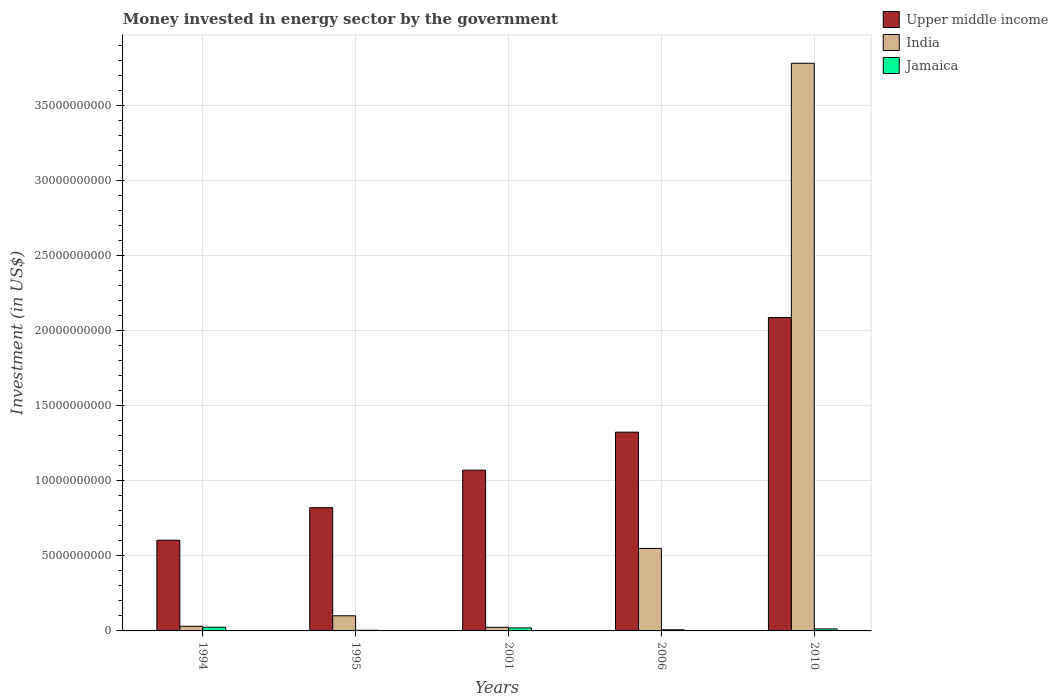How many different coloured bars are there?
Your response must be concise. 3. How many groups of bars are there?
Provide a short and direct response. 5. Are the number of bars per tick equal to the number of legend labels?
Make the answer very short. Yes. Are the number of bars on each tick of the X-axis equal?
Provide a succinct answer. Yes. How many bars are there on the 3rd tick from the right?
Offer a very short reply. 3. What is the label of the 4th group of bars from the left?
Your answer should be compact. 2006. In how many cases, is the number of bars for a given year not equal to the number of legend labels?
Provide a succinct answer. 0. What is the money spent in energy sector in Upper middle income in 1995?
Give a very brief answer. 8.21e+09. Across all years, what is the maximum money spent in energy sector in Jamaica?
Ensure brevity in your answer.  2.46e+08. Across all years, what is the minimum money spent in energy sector in India?
Your answer should be very brief. 2.40e+08. In which year was the money spent in energy sector in India minimum?
Offer a very short reply. 2001. What is the total money spent in energy sector in Jamaica in the graph?
Your answer should be compact. 7.00e+08. What is the difference between the money spent in energy sector in Jamaica in 2001 and that in 2006?
Offer a terse response. 1.23e+08. What is the difference between the money spent in energy sector in India in 2001 and the money spent in energy sector in Upper middle income in 1995?
Offer a terse response. -7.97e+09. What is the average money spent in energy sector in India per year?
Provide a short and direct response. 8.98e+09. In the year 2010, what is the difference between the money spent in energy sector in Jamaica and money spent in energy sector in Upper middle income?
Ensure brevity in your answer.  -2.08e+1. In how many years, is the money spent in energy sector in Jamaica greater than 34000000000 US$?
Your response must be concise. 0. What is the ratio of the money spent in energy sector in India in 2006 to that in 2010?
Offer a terse response. 0.15. Is the money spent in energy sector in Jamaica in 2006 less than that in 2010?
Provide a short and direct response. Yes. What is the difference between the highest and the second highest money spent in energy sector in Jamaica?
Give a very brief answer. 4.50e+07. What is the difference between the highest and the lowest money spent in energy sector in Upper middle income?
Your answer should be compact. 1.48e+1. In how many years, is the money spent in energy sector in India greater than the average money spent in energy sector in India taken over all years?
Provide a succinct answer. 1. What does the 1st bar from the left in 1994 represents?
Make the answer very short. Upper middle income. What does the 1st bar from the right in 2010 represents?
Offer a very short reply. Jamaica. How many years are there in the graph?
Offer a terse response. 5. What is the difference between two consecutive major ticks on the Y-axis?
Keep it short and to the point. 5.00e+09. Are the values on the major ticks of Y-axis written in scientific E-notation?
Give a very brief answer. No. How many legend labels are there?
Keep it short and to the point. 3. What is the title of the graph?
Provide a succinct answer. Money invested in energy sector by the government. Does "Isle of Man" appear as one of the legend labels in the graph?
Give a very brief answer. No. What is the label or title of the Y-axis?
Your response must be concise. Investment (in US$). What is the Investment (in US$) in Upper middle income in 1994?
Provide a succinct answer. 6.05e+09. What is the Investment (in US$) in India in 1994?
Keep it short and to the point. 3.11e+08. What is the Investment (in US$) in Jamaica in 1994?
Provide a short and direct response. 2.46e+08. What is the Investment (in US$) in Upper middle income in 1995?
Provide a succinct answer. 8.21e+09. What is the Investment (in US$) of India in 1995?
Provide a succinct answer. 1.01e+09. What is the Investment (in US$) in Jamaica in 1995?
Give a very brief answer. 4.30e+07. What is the Investment (in US$) of Upper middle income in 2001?
Provide a succinct answer. 1.07e+1. What is the Investment (in US$) of India in 2001?
Provide a succinct answer. 2.40e+08. What is the Investment (in US$) in Jamaica in 2001?
Your answer should be very brief. 2.01e+08. What is the Investment (in US$) in Upper middle income in 2006?
Your answer should be very brief. 1.32e+1. What is the Investment (in US$) in India in 2006?
Offer a very short reply. 5.50e+09. What is the Investment (in US$) of Jamaica in 2006?
Provide a short and direct response. 7.80e+07. What is the Investment (in US$) of Upper middle income in 2010?
Provide a short and direct response. 2.09e+1. What is the Investment (in US$) of India in 2010?
Offer a terse response. 3.78e+1. What is the Investment (in US$) in Jamaica in 2010?
Your response must be concise. 1.32e+08. Across all years, what is the maximum Investment (in US$) of Upper middle income?
Your response must be concise. 2.09e+1. Across all years, what is the maximum Investment (in US$) in India?
Ensure brevity in your answer.  3.78e+1. Across all years, what is the maximum Investment (in US$) of Jamaica?
Provide a short and direct response. 2.46e+08. Across all years, what is the minimum Investment (in US$) in Upper middle income?
Keep it short and to the point. 6.05e+09. Across all years, what is the minimum Investment (in US$) in India?
Make the answer very short. 2.40e+08. Across all years, what is the minimum Investment (in US$) in Jamaica?
Ensure brevity in your answer.  4.30e+07. What is the total Investment (in US$) of Upper middle income in the graph?
Provide a short and direct response. 5.91e+1. What is the total Investment (in US$) of India in the graph?
Keep it short and to the point. 4.49e+1. What is the total Investment (in US$) in Jamaica in the graph?
Give a very brief answer. 7.00e+08. What is the difference between the Investment (in US$) in Upper middle income in 1994 and that in 1995?
Make the answer very short. -2.17e+09. What is the difference between the Investment (in US$) of India in 1994 and that in 1995?
Keep it short and to the point. -6.97e+08. What is the difference between the Investment (in US$) in Jamaica in 1994 and that in 1995?
Give a very brief answer. 2.03e+08. What is the difference between the Investment (in US$) of Upper middle income in 1994 and that in 2001?
Your answer should be very brief. -4.67e+09. What is the difference between the Investment (in US$) of India in 1994 and that in 2001?
Offer a very short reply. 7.13e+07. What is the difference between the Investment (in US$) of Jamaica in 1994 and that in 2001?
Offer a very short reply. 4.50e+07. What is the difference between the Investment (in US$) in Upper middle income in 1994 and that in 2006?
Your answer should be very brief. -7.20e+09. What is the difference between the Investment (in US$) of India in 1994 and that in 2006?
Provide a succinct answer. -5.19e+09. What is the difference between the Investment (in US$) in Jamaica in 1994 and that in 2006?
Offer a very short reply. 1.68e+08. What is the difference between the Investment (in US$) of Upper middle income in 1994 and that in 2010?
Keep it short and to the point. -1.48e+1. What is the difference between the Investment (in US$) in India in 1994 and that in 2010?
Offer a terse response. -3.75e+1. What is the difference between the Investment (in US$) of Jamaica in 1994 and that in 2010?
Ensure brevity in your answer.  1.14e+08. What is the difference between the Investment (in US$) in Upper middle income in 1995 and that in 2001?
Provide a short and direct response. -2.50e+09. What is the difference between the Investment (in US$) in India in 1995 and that in 2001?
Offer a very short reply. 7.68e+08. What is the difference between the Investment (in US$) of Jamaica in 1995 and that in 2001?
Provide a succinct answer. -1.58e+08. What is the difference between the Investment (in US$) of Upper middle income in 1995 and that in 2006?
Offer a very short reply. -5.04e+09. What is the difference between the Investment (in US$) of India in 1995 and that in 2006?
Your answer should be very brief. -4.49e+09. What is the difference between the Investment (in US$) of Jamaica in 1995 and that in 2006?
Make the answer very short. -3.50e+07. What is the difference between the Investment (in US$) of Upper middle income in 1995 and that in 2010?
Ensure brevity in your answer.  -1.27e+1. What is the difference between the Investment (in US$) of India in 1995 and that in 2010?
Provide a short and direct response. -3.68e+1. What is the difference between the Investment (in US$) in Jamaica in 1995 and that in 2010?
Your answer should be compact. -8.90e+07. What is the difference between the Investment (in US$) in Upper middle income in 2001 and that in 2006?
Give a very brief answer. -2.54e+09. What is the difference between the Investment (in US$) of India in 2001 and that in 2006?
Your answer should be compact. -5.26e+09. What is the difference between the Investment (in US$) in Jamaica in 2001 and that in 2006?
Your answer should be compact. 1.23e+08. What is the difference between the Investment (in US$) of Upper middle income in 2001 and that in 2010?
Your answer should be very brief. -1.02e+1. What is the difference between the Investment (in US$) of India in 2001 and that in 2010?
Offer a very short reply. -3.76e+1. What is the difference between the Investment (in US$) of Jamaica in 2001 and that in 2010?
Provide a succinct answer. 6.90e+07. What is the difference between the Investment (in US$) of Upper middle income in 2006 and that in 2010?
Make the answer very short. -7.64e+09. What is the difference between the Investment (in US$) in India in 2006 and that in 2010?
Ensure brevity in your answer.  -3.23e+1. What is the difference between the Investment (in US$) in Jamaica in 2006 and that in 2010?
Offer a terse response. -5.40e+07. What is the difference between the Investment (in US$) of Upper middle income in 1994 and the Investment (in US$) of India in 1995?
Ensure brevity in your answer.  5.04e+09. What is the difference between the Investment (in US$) of Upper middle income in 1994 and the Investment (in US$) of Jamaica in 1995?
Give a very brief answer. 6.00e+09. What is the difference between the Investment (in US$) in India in 1994 and the Investment (in US$) in Jamaica in 1995?
Make the answer very short. 2.68e+08. What is the difference between the Investment (in US$) in Upper middle income in 1994 and the Investment (in US$) in India in 2001?
Offer a terse response. 5.81e+09. What is the difference between the Investment (in US$) of Upper middle income in 1994 and the Investment (in US$) of Jamaica in 2001?
Your answer should be very brief. 5.84e+09. What is the difference between the Investment (in US$) in India in 1994 and the Investment (in US$) in Jamaica in 2001?
Give a very brief answer. 1.10e+08. What is the difference between the Investment (in US$) of Upper middle income in 1994 and the Investment (in US$) of India in 2006?
Ensure brevity in your answer.  5.45e+08. What is the difference between the Investment (in US$) of Upper middle income in 1994 and the Investment (in US$) of Jamaica in 2006?
Ensure brevity in your answer.  5.97e+09. What is the difference between the Investment (in US$) of India in 1994 and the Investment (in US$) of Jamaica in 2006?
Keep it short and to the point. 2.33e+08. What is the difference between the Investment (in US$) in Upper middle income in 1994 and the Investment (in US$) in India in 2010?
Make the answer very short. -3.18e+1. What is the difference between the Investment (in US$) in Upper middle income in 1994 and the Investment (in US$) in Jamaica in 2010?
Provide a succinct answer. 5.91e+09. What is the difference between the Investment (in US$) of India in 1994 and the Investment (in US$) of Jamaica in 2010?
Your answer should be compact. 1.79e+08. What is the difference between the Investment (in US$) of Upper middle income in 1995 and the Investment (in US$) of India in 2001?
Your response must be concise. 7.97e+09. What is the difference between the Investment (in US$) in Upper middle income in 1995 and the Investment (in US$) in Jamaica in 2001?
Offer a terse response. 8.01e+09. What is the difference between the Investment (in US$) of India in 1995 and the Investment (in US$) of Jamaica in 2001?
Provide a short and direct response. 8.07e+08. What is the difference between the Investment (in US$) in Upper middle income in 1995 and the Investment (in US$) in India in 2006?
Provide a short and direct response. 2.71e+09. What is the difference between the Investment (in US$) in Upper middle income in 1995 and the Investment (in US$) in Jamaica in 2006?
Provide a short and direct response. 8.14e+09. What is the difference between the Investment (in US$) in India in 1995 and the Investment (in US$) in Jamaica in 2006?
Your answer should be compact. 9.30e+08. What is the difference between the Investment (in US$) of Upper middle income in 1995 and the Investment (in US$) of India in 2010?
Provide a short and direct response. -2.96e+1. What is the difference between the Investment (in US$) of Upper middle income in 1995 and the Investment (in US$) of Jamaica in 2010?
Your response must be concise. 8.08e+09. What is the difference between the Investment (in US$) in India in 1995 and the Investment (in US$) in Jamaica in 2010?
Provide a short and direct response. 8.76e+08. What is the difference between the Investment (in US$) of Upper middle income in 2001 and the Investment (in US$) of India in 2006?
Make the answer very short. 5.21e+09. What is the difference between the Investment (in US$) of Upper middle income in 2001 and the Investment (in US$) of Jamaica in 2006?
Offer a very short reply. 1.06e+1. What is the difference between the Investment (in US$) of India in 2001 and the Investment (in US$) of Jamaica in 2006?
Ensure brevity in your answer.  1.62e+08. What is the difference between the Investment (in US$) in Upper middle income in 2001 and the Investment (in US$) in India in 2010?
Make the answer very short. -2.71e+1. What is the difference between the Investment (in US$) in Upper middle income in 2001 and the Investment (in US$) in Jamaica in 2010?
Offer a terse response. 1.06e+1. What is the difference between the Investment (in US$) in India in 2001 and the Investment (in US$) in Jamaica in 2010?
Offer a terse response. 1.08e+08. What is the difference between the Investment (in US$) of Upper middle income in 2006 and the Investment (in US$) of India in 2010?
Make the answer very short. -2.46e+1. What is the difference between the Investment (in US$) of Upper middle income in 2006 and the Investment (in US$) of Jamaica in 2010?
Your answer should be very brief. 1.31e+1. What is the difference between the Investment (in US$) of India in 2006 and the Investment (in US$) of Jamaica in 2010?
Provide a succinct answer. 5.37e+09. What is the average Investment (in US$) of Upper middle income per year?
Keep it short and to the point. 1.18e+1. What is the average Investment (in US$) in India per year?
Offer a very short reply. 8.98e+09. What is the average Investment (in US$) of Jamaica per year?
Ensure brevity in your answer.  1.40e+08. In the year 1994, what is the difference between the Investment (in US$) in Upper middle income and Investment (in US$) in India?
Keep it short and to the point. 5.73e+09. In the year 1994, what is the difference between the Investment (in US$) in Upper middle income and Investment (in US$) in Jamaica?
Keep it short and to the point. 5.80e+09. In the year 1994, what is the difference between the Investment (in US$) in India and Investment (in US$) in Jamaica?
Your answer should be compact. 6.53e+07. In the year 1995, what is the difference between the Investment (in US$) in Upper middle income and Investment (in US$) in India?
Ensure brevity in your answer.  7.21e+09. In the year 1995, what is the difference between the Investment (in US$) in Upper middle income and Investment (in US$) in Jamaica?
Make the answer very short. 8.17e+09. In the year 1995, what is the difference between the Investment (in US$) of India and Investment (in US$) of Jamaica?
Your response must be concise. 9.65e+08. In the year 2001, what is the difference between the Investment (in US$) in Upper middle income and Investment (in US$) in India?
Your answer should be compact. 1.05e+1. In the year 2001, what is the difference between the Investment (in US$) in Upper middle income and Investment (in US$) in Jamaica?
Offer a very short reply. 1.05e+1. In the year 2001, what is the difference between the Investment (in US$) in India and Investment (in US$) in Jamaica?
Provide a succinct answer. 3.90e+07. In the year 2006, what is the difference between the Investment (in US$) in Upper middle income and Investment (in US$) in India?
Keep it short and to the point. 7.75e+09. In the year 2006, what is the difference between the Investment (in US$) in Upper middle income and Investment (in US$) in Jamaica?
Provide a short and direct response. 1.32e+1. In the year 2006, what is the difference between the Investment (in US$) in India and Investment (in US$) in Jamaica?
Give a very brief answer. 5.42e+09. In the year 2010, what is the difference between the Investment (in US$) in Upper middle income and Investment (in US$) in India?
Your response must be concise. -1.70e+1. In the year 2010, what is the difference between the Investment (in US$) in Upper middle income and Investment (in US$) in Jamaica?
Your response must be concise. 2.08e+1. In the year 2010, what is the difference between the Investment (in US$) in India and Investment (in US$) in Jamaica?
Your response must be concise. 3.77e+1. What is the ratio of the Investment (in US$) in Upper middle income in 1994 to that in 1995?
Make the answer very short. 0.74. What is the ratio of the Investment (in US$) of India in 1994 to that in 1995?
Your answer should be compact. 0.31. What is the ratio of the Investment (in US$) in Jamaica in 1994 to that in 1995?
Your answer should be compact. 5.72. What is the ratio of the Investment (in US$) of Upper middle income in 1994 to that in 2001?
Provide a succinct answer. 0.56. What is the ratio of the Investment (in US$) in India in 1994 to that in 2001?
Provide a succinct answer. 1.3. What is the ratio of the Investment (in US$) of Jamaica in 1994 to that in 2001?
Make the answer very short. 1.22. What is the ratio of the Investment (in US$) in Upper middle income in 1994 to that in 2006?
Provide a succinct answer. 0.46. What is the ratio of the Investment (in US$) in India in 1994 to that in 2006?
Your answer should be compact. 0.06. What is the ratio of the Investment (in US$) in Jamaica in 1994 to that in 2006?
Offer a very short reply. 3.15. What is the ratio of the Investment (in US$) of Upper middle income in 1994 to that in 2010?
Offer a very short reply. 0.29. What is the ratio of the Investment (in US$) of India in 1994 to that in 2010?
Your answer should be very brief. 0.01. What is the ratio of the Investment (in US$) of Jamaica in 1994 to that in 2010?
Ensure brevity in your answer.  1.86. What is the ratio of the Investment (in US$) of Upper middle income in 1995 to that in 2001?
Your answer should be very brief. 0.77. What is the ratio of the Investment (in US$) in India in 1995 to that in 2001?
Offer a very short reply. 4.2. What is the ratio of the Investment (in US$) of Jamaica in 1995 to that in 2001?
Make the answer very short. 0.21. What is the ratio of the Investment (in US$) of Upper middle income in 1995 to that in 2006?
Make the answer very short. 0.62. What is the ratio of the Investment (in US$) of India in 1995 to that in 2006?
Ensure brevity in your answer.  0.18. What is the ratio of the Investment (in US$) in Jamaica in 1995 to that in 2006?
Provide a succinct answer. 0.55. What is the ratio of the Investment (in US$) of Upper middle income in 1995 to that in 2010?
Keep it short and to the point. 0.39. What is the ratio of the Investment (in US$) of India in 1995 to that in 2010?
Offer a very short reply. 0.03. What is the ratio of the Investment (in US$) of Jamaica in 1995 to that in 2010?
Your response must be concise. 0.33. What is the ratio of the Investment (in US$) in Upper middle income in 2001 to that in 2006?
Provide a succinct answer. 0.81. What is the ratio of the Investment (in US$) in India in 2001 to that in 2006?
Ensure brevity in your answer.  0.04. What is the ratio of the Investment (in US$) of Jamaica in 2001 to that in 2006?
Provide a short and direct response. 2.58. What is the ratio of the Investment (in US$) of Upper middle income in 2001 to that in 2010?
Offer a very short reply. 0.51. What is the ratio of the Investment (in US$) of India in 2001 to that in 2010?
Ensure brevity in your answer.  0.01. What is the ratio of the Investment (in US$) of Jamaica in 2001 to that in 2010?
Ensure brevity in your answer.  1.52. What is the ratio of the Investment (in US$) in Upper middle income in 2006 to that in 2010?
Your answer should be compact. 0.63. What is the ratio of the Investment (in US$) of India in 2006 to that in 2010?
Offer a terse response. 0.15. What is the ratio of the Investment (in US$) in Jamaica in 2006 to that in 2010?
Offer a terse response. 0.59. What is the difference between the highest and the second highest Investment (in US$) of Upper middle income?
Your response must be concise. 7.64e+09. What is the difference between the highest and the second highest Investment (in US$) in India?
Make the answer very short. 3.23e+1. What is the difference between the highest and the second highest Investment (in US$) in Jamaica?
Offer a terse response. 4.50e+07. What is the difference between the highest and the lowest Investment (in US$) of Upper middle income?
Ensure brevity in your answer.  1.48e+1. What is the difference between the highest and the lowest Investment (in US$) in India?
Offer a terse response. 3.76e+1. What is the difference between the highest and the lowest Investment (in US$) of Jamaica?
Keep it short and to the point. 2.03e+08. 